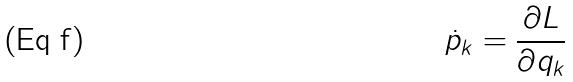<formula> <loc_0><loc_0><loc_500><loc_500>\dot { p } _ { k } = \frac { \partial L } { \partial q _ { k } }</formula> 